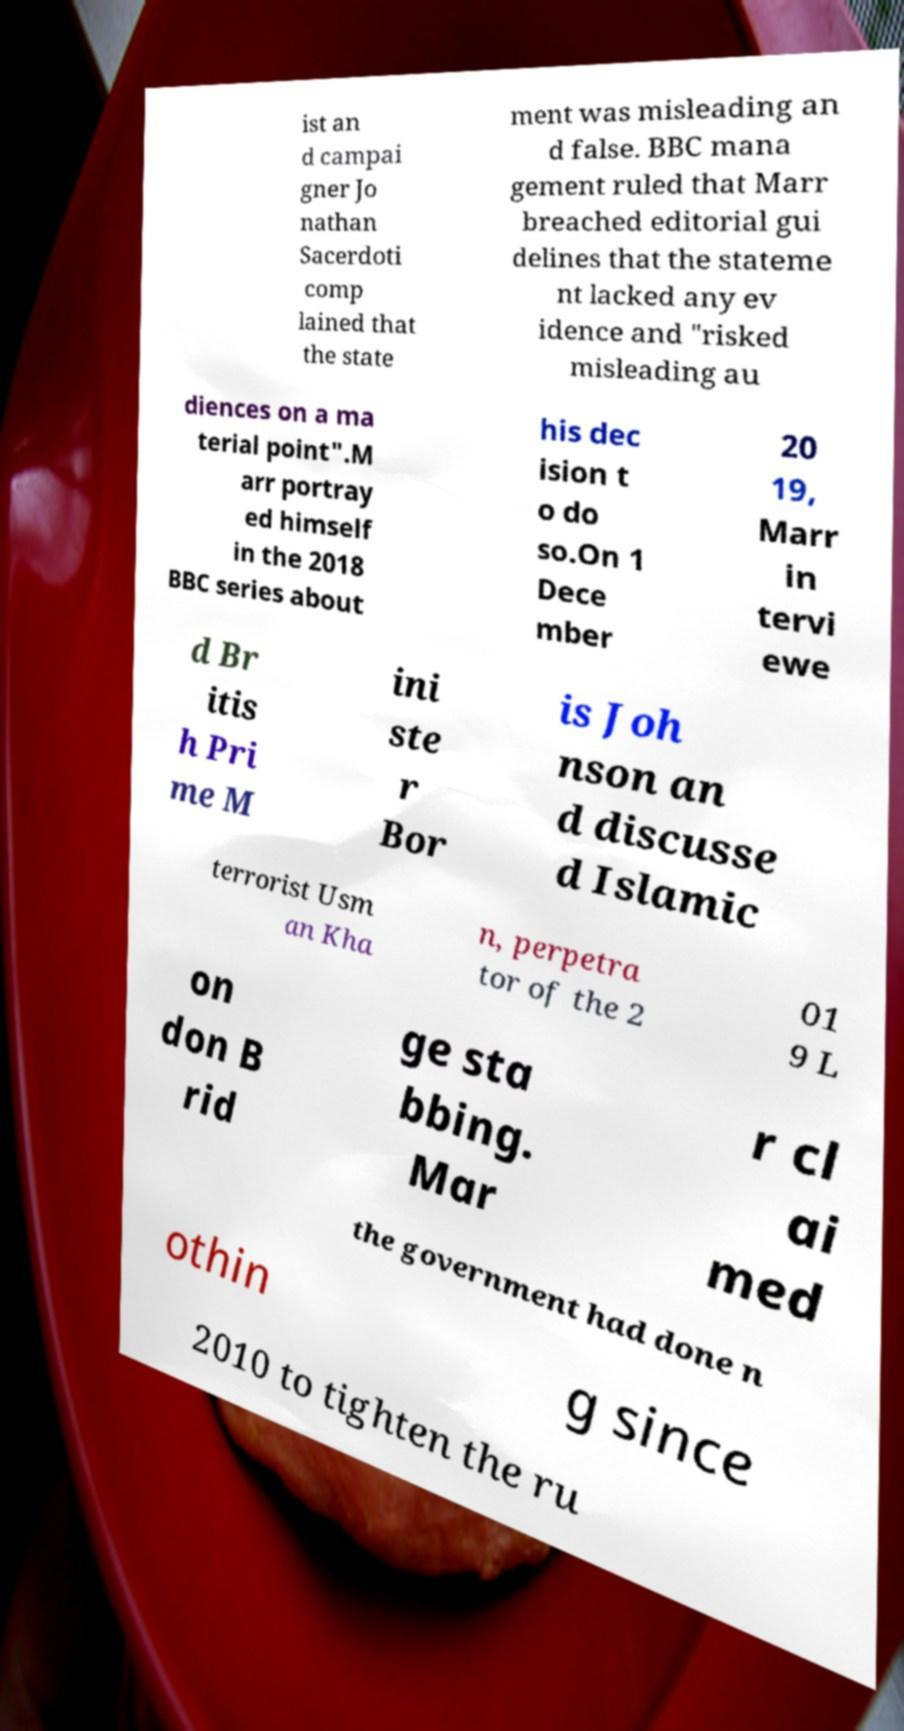Can you read and provide the text displayed in the image?This photo seems to have some interesting text. Can you extract and type it out for me? ist an d campai gner Jo nathan Sacerdoti comp lained that the state ment was misleading an d false. BBC mana gement ruled that Marr breached editorial gui delines that the stateme nt lacked any ev idence and "risked misleading au diences on a ma terial point".M arr portray ed himself in the 2018 BBC series about his dec ision t o do so.On 1 Dece mber 20 19, Marr in tervi ewe d Br itis h Pri me M ini ste r Bor is Joh nson an d discusse d Islamic terrorist Usm an Kha n, perpetra tor of the 2 01 9 L on don B rid ge sta bbing. Mar r cl ai med the government had done n othin g since 2010 to tighten the ru 